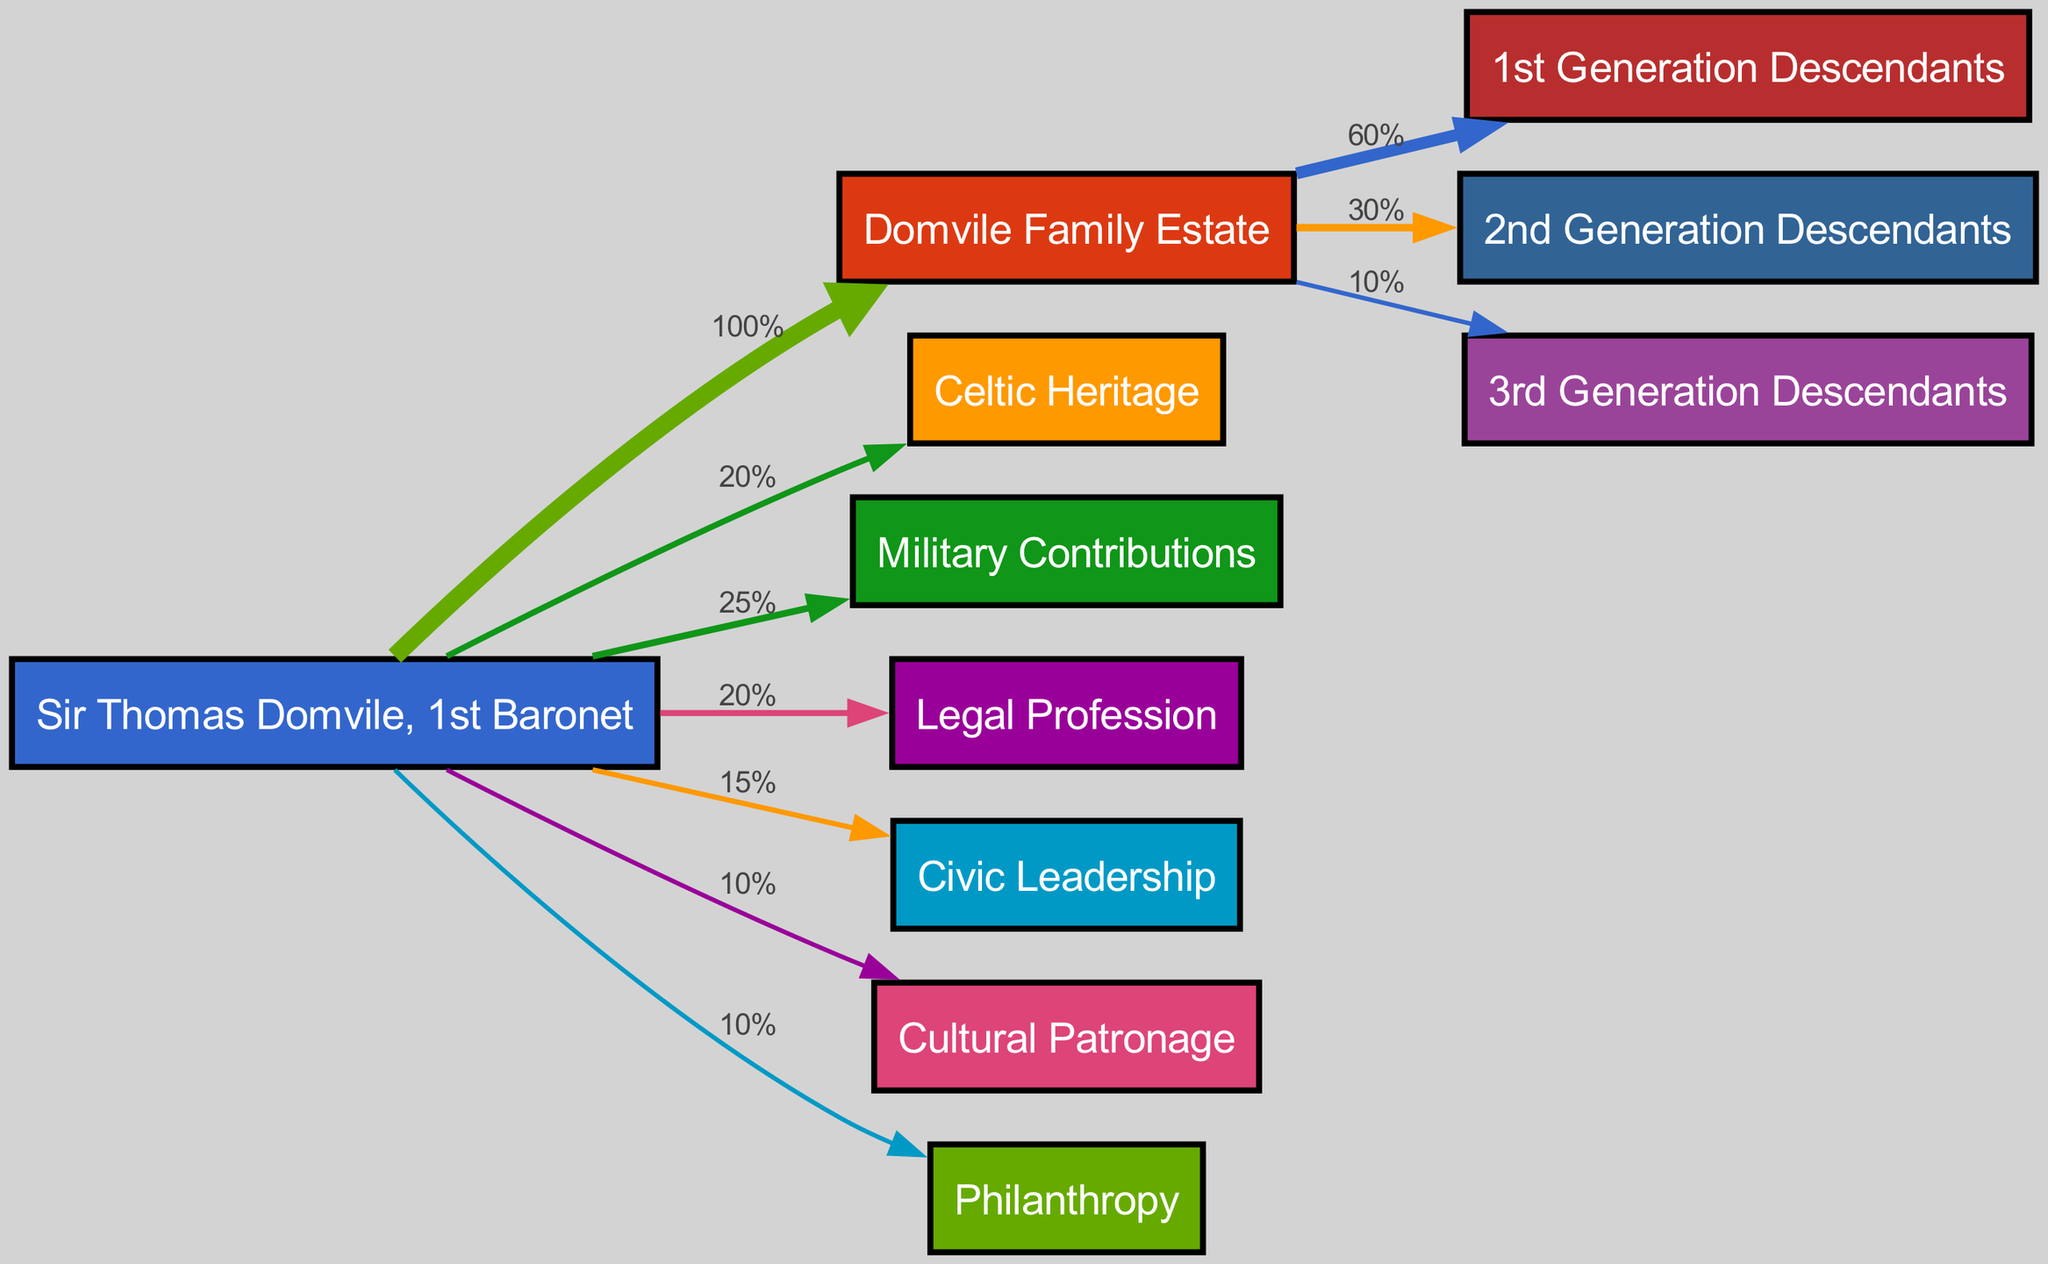What percentage of the Domvile Family Estate goes to the 1st Generation Descendants? The diagram shows a direct link from "Domvile Family Estate" to "1st Generation Descendants" with a value of 60%.
Answer: 60% What is the total number of descendants represented in the diagram? There are three groups of descendants listed: "1st Generation Descendants," "2nd Generation Descendants," and "3rd Generation Descendants," which totals to 3.
Answer: 3 Which contribution has the highest percentage attributed to Sir Thomas Domvile, 1st Baronet? By examining the links originating from "Sir Thomas Domvile, 1st Baronet," the "Military Contributions" link shows the highest value of 25%.
Answer: Military Contributions What is the total percentage of the Domvile Family Estate legacy received by the 2nd Generation Descendants? The diagram shows a direct link from "Domvile Family Estate" to "2nd Generation Descendants" with a value of 30%.
Answer: 30% How much percentage of Sir Thomas Domvile, 1st Baronet's contributions is attributed to Cultural Patronage? The flow from "Sir Thomas Domvile, 1st Baronet" to "Cultural Patronage" indicates a contribution of 10%.
Answer: 10% What is the overall percentage distribution of the Domvile Family Estate among all descendants? The total percentage of the estate is distributed as follows: 60% to 1st Generation, 30% to 2nd Generation, and 10% to 3rd Generation, summing up to 100%.
Answer: 100% Which area of contribution has the lowest percentage from Sir Thomas Domvile, 1st Baronet? Looking at the contributions, "Cultural Patronage" and "Philanthropy" both have the lowest link percentage of 10%.
Answer: Cultural Patronage What percentage of Sir Thomas Domvile, 1st Baronet's contributions goes to Civic Leadership? The diagram indicates that "Civic Leadership" has a contribution value of 15%.
Answer: 15% 